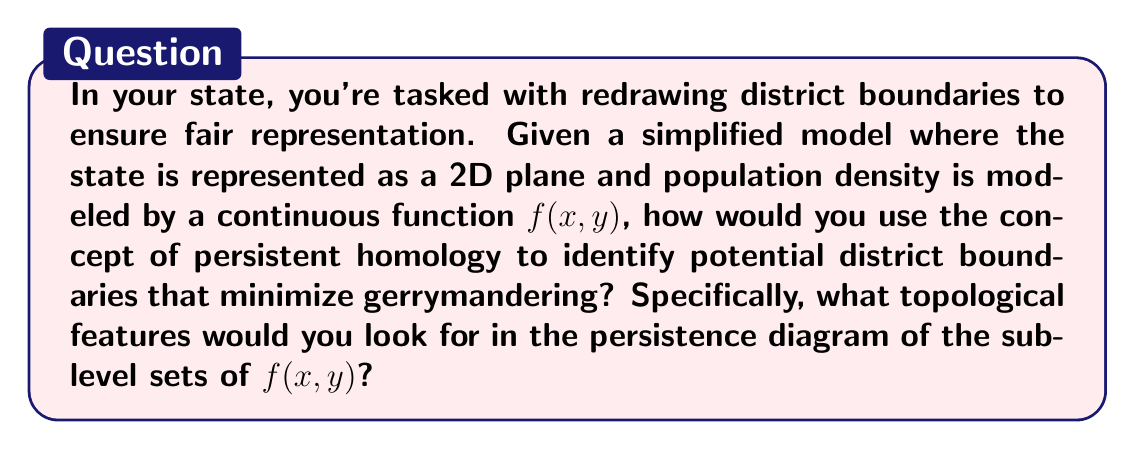Provide a solution to this math problem. To approach this problem, we'll use concepts from algebraic topology and persistent homology:

1. Model the state:
   The state is represented as a 2D plane with a population density function $f(x,y)$.

2. Understand sublevel sets:
   For each threshold $t$, define the sublevel set $S_t = \{(x,y) | f(x,y) \leq t\}$.

3. Compute persistent homology:
   As $t$ increases, track the birth and death of topological features (connected components, loops) in $S_t$.

4. Analyze the persistence diagram:
   - Plot birth vs. death times for each feature.
   - Long-lived features (far from the diagonal) are significant.

5. Interpret for districting:
   - Connected components represent population centers.
   - Loops may indicate natural boundaries or corridors between population centers.

6. Identify optimal boundaries:
   - Look for stable, long-lived features in the persistence diagram.
   - Connected components suggest district cores.
   - Loops might indicate boundaries between districts.

7. Minimize gerrymandering:
   - Prefer boundaries based on significant topological features.
   - Avoid cutting through long-lived connected components.
   - Use natural corridors (loops) as district separators.

8. Ensure fair representation:
   - Balance population between districts using the integral of $f(x,y)$ over each region.
   - Adjust boundaries to achieve population equity while respecting topological features.

By focusing on persistent topological features, you can create district boundaries that respect natural population distributions and geographical features, reducing the potential for gerrymandering and ensuring more fair representation.
Answer: Long-lived connected components and loops in the persistence diagram of $f(x,y)$'s sublevel sets. 